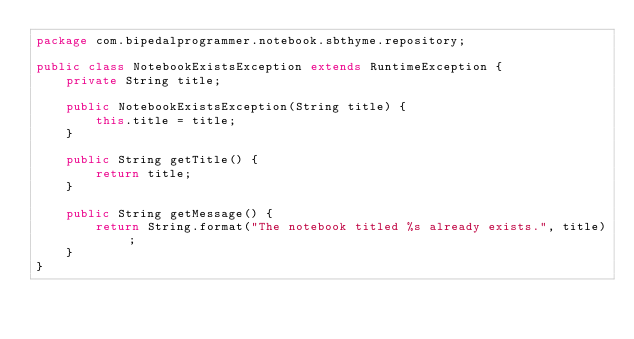<code> <loc_0><loc_0><loc_500><loc_500><_Java_>package com.bipedalprogrammer.notebook.sbthyme.repository;

public class NotebookExistsException extends RuntimeException {
    private String title;

    public NotebookExistsException(String title) {
        this.title = title;
    }

    public String getTitle() {
        return title;
    }

    public String getMessage() {
        return String.format("The notebook titled %s already exists.", title);
    }
}
</code> 